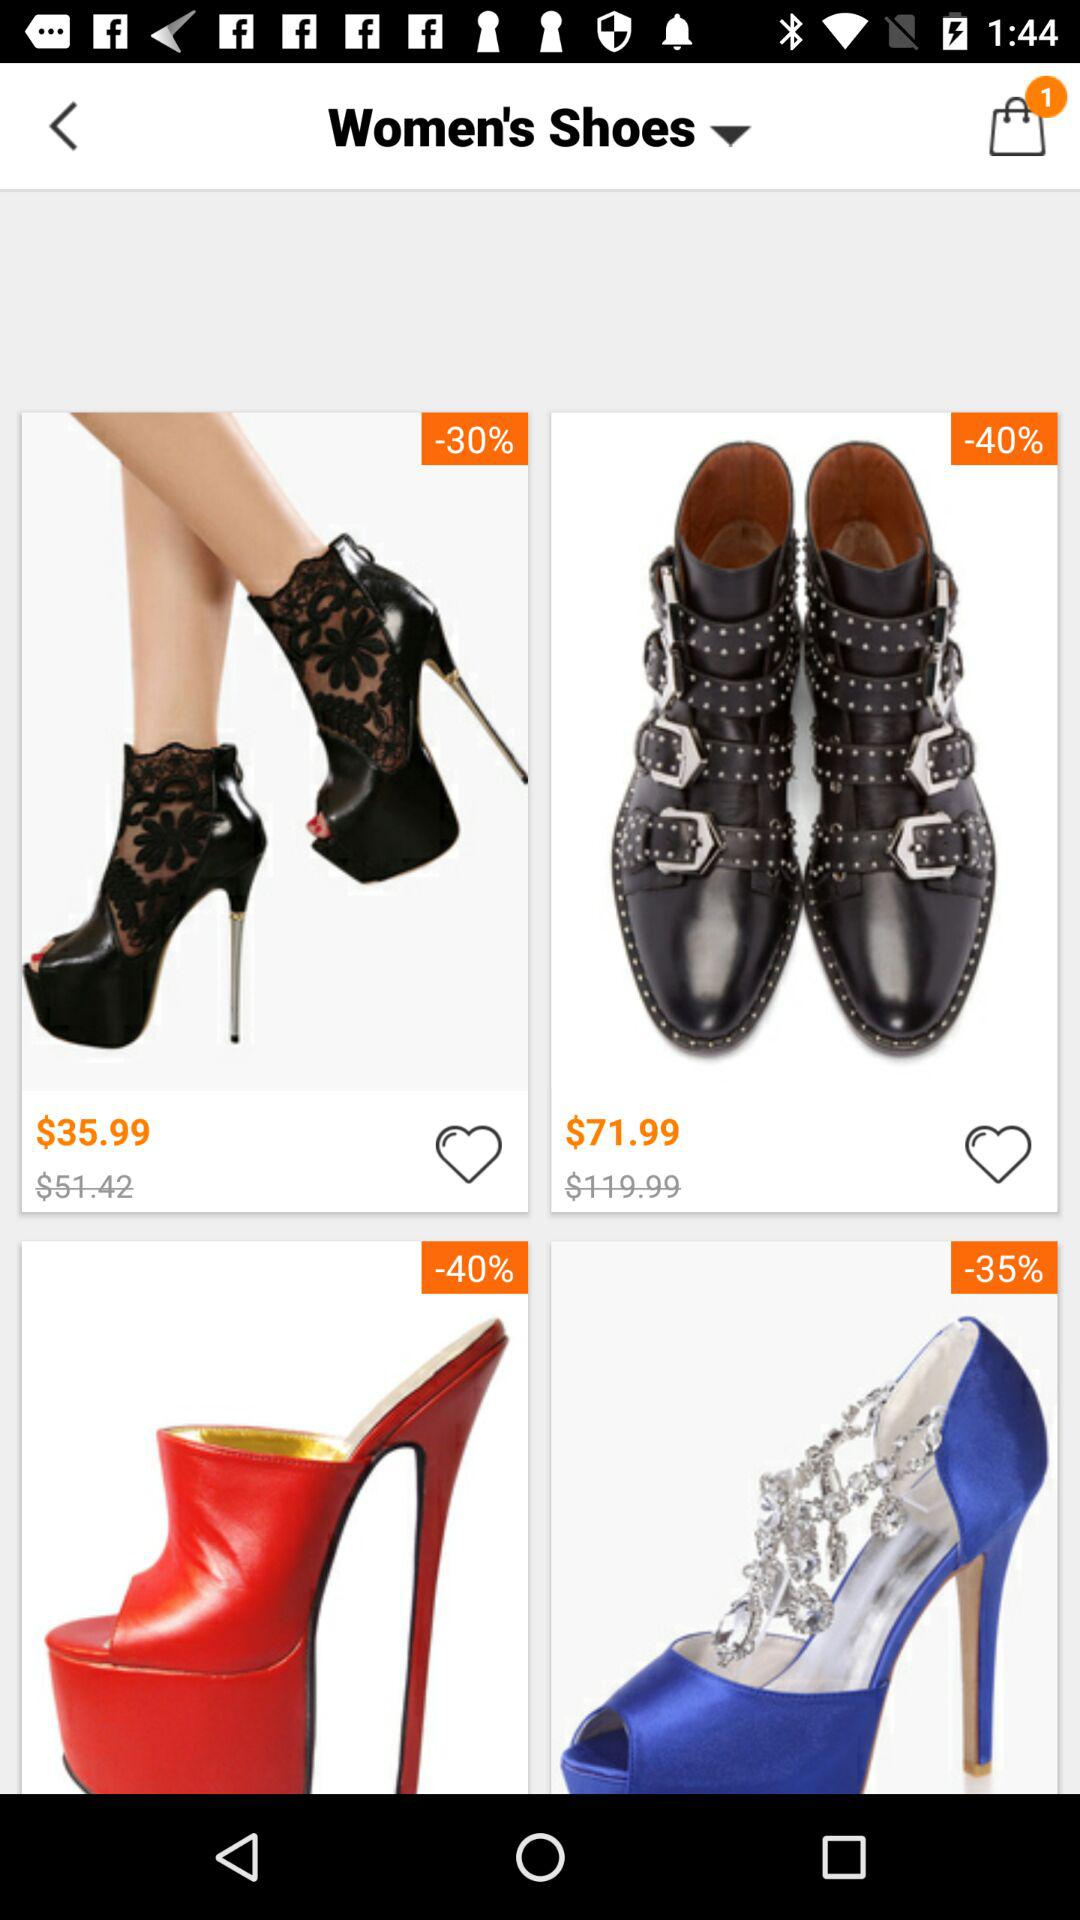What is the price of women's shoes with 30% off? The price of women's shoes with 30% off is $35.99. 